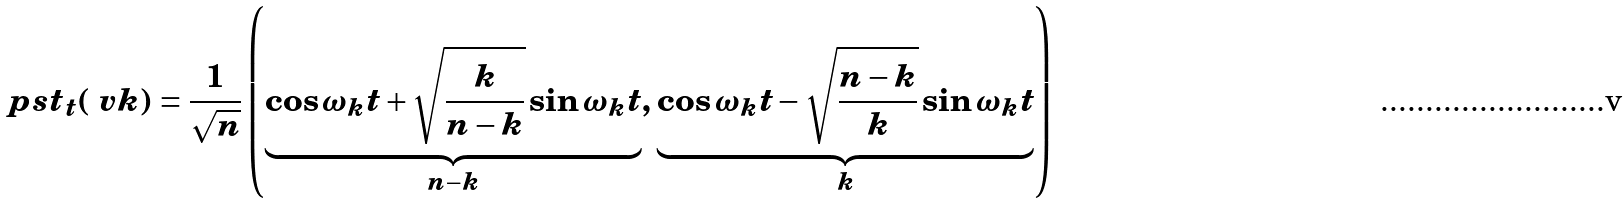<formula> <loc_0><loc_0><loc_500><loc_500>\ p s t _ { t } ( \ v k ) = \frac { 1 } { \sqrt { n } } \left ( \underbrace { \cos \omega _ { k } t + \sqrt { \frac { k } { n - k } } \sin \omega _ { k } t } _ { n - k } , \, \underbrace { \cos \omega _ { k } t - \sqrt { \frac { n - k } { k } } \sin \omega _ { k } t } _ { k } \right )</formula> 